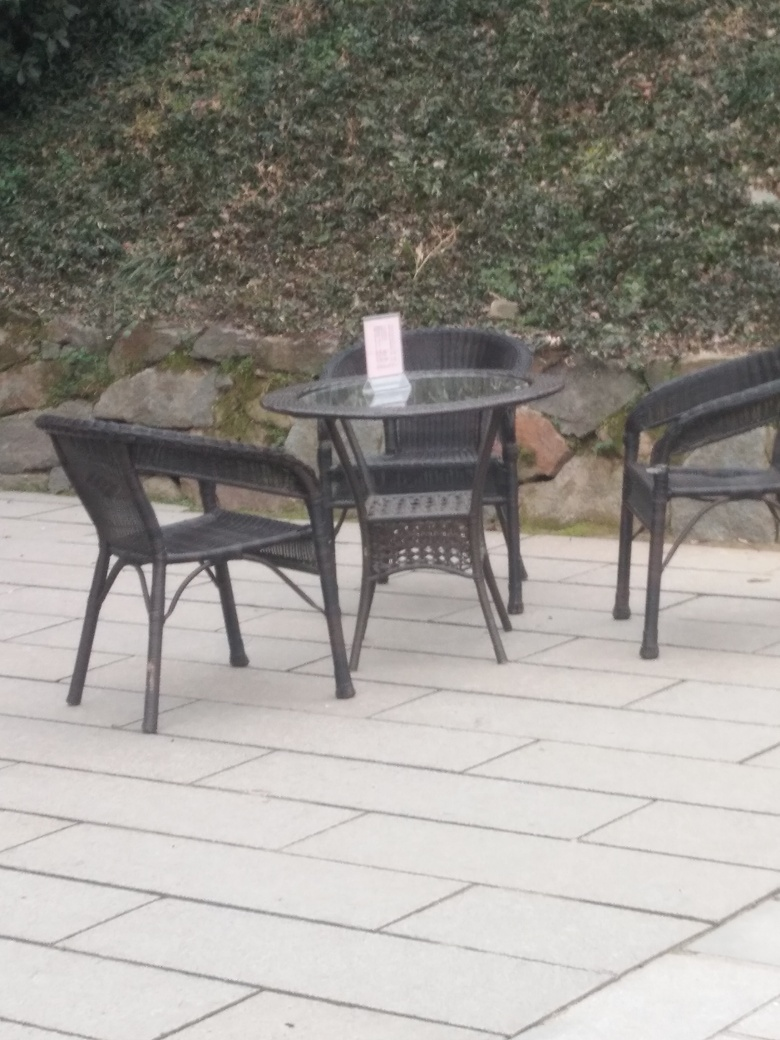Can you describe the setting in which the chair and table are placed? Certainly! The chair and table are situated outdoors, likely part of a cafe or restaurant patio. The setting is casual with a paved floor, and a natural backdrop of dense shrubbery lines the area, suggesting a pleasant space for dining or relaxation. 